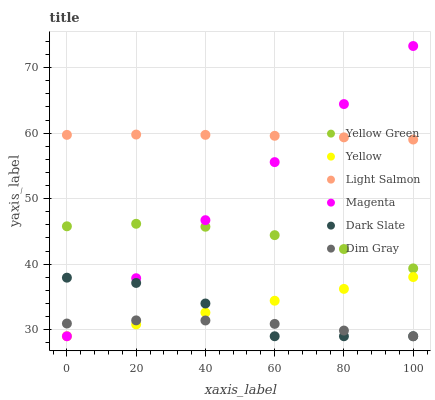Does Dim Gray have the minimum area under the curve?
Answer yes or no. Yes. Does Light Salmon have the maximum area under the curve?
Answer yes or no. Yes. Does Yellow Green have the minimum area under the curve?
Answer yes or no. No. Does Yellow Green have the maximum area under the curve?
Answer yes or no. No. Is Magenta the smoothest?
Answer yes or no. Yes. Is Dark Slate the roughest?
Answer yes or no. Yes. Is Dim Gray the smoothest?
Answer yes or no. No. Is Dim Gray the roughest?
Answer yes or no. No. Does Dim Gray have the lowest value?
Answer yes or no. Yes. Does Yellow Green have the lowest value?
Answer yes or no. No. Does Magenta have the highest value?
Answer yes or no. Yes. Does Yellow Green have the highest value?
Answer yes or no. No. Is Dark Slate less than Yellow Green?
Answer yes or no. Yes. Is Light Salmon greater than Yellow?
Answer yes or no. Yes. Does Magenta intersect Dim Gray?
Answer yes or no. Yes. Is Magenta less than Dim Gray?
Answer yes or no. No. Is Magenta greater than Dim Gray?
Answer yes or no. No. Does Dark Slate intersect Yellow Green?
Answer yes or no. No. 